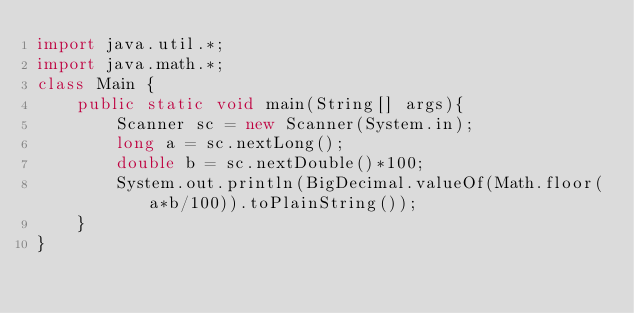Convert code to text. <code><loc_0><loc_0><loc_500><loc_500><_Java_>import java.util.*;
import java.math.*;
class Main {
    public static void main(String[] args){
        Scanner sc = new Scanner(System.in);
        long a = sc.nextLong();
        double b = sc.nextDouble()*100;
        System.out.println(BigDecimal.valueOf(Math.floor(a*b/100)).toPlainString());
    }
}</code> 